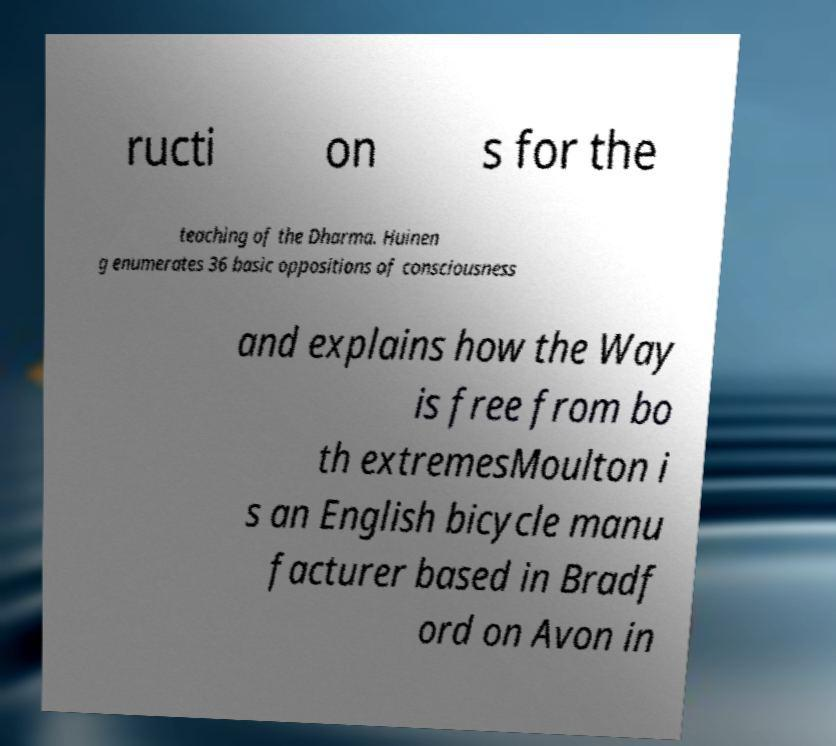Please identify and transcribe the text found in this image. ructi on s for the teaching of the Dharma. Huinen g enumerates 36 basic oppositions of consciousness and explains how the Way is free from bo th extremesMoulton i s an English bicycle manu facturer based in Bradf ord on Avon in 